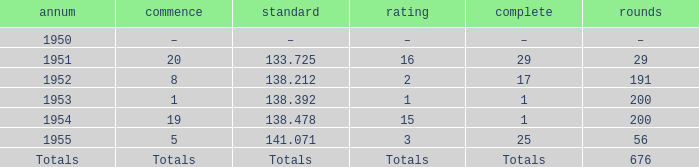How many laps does the one ranked 16 have? 29.0. 